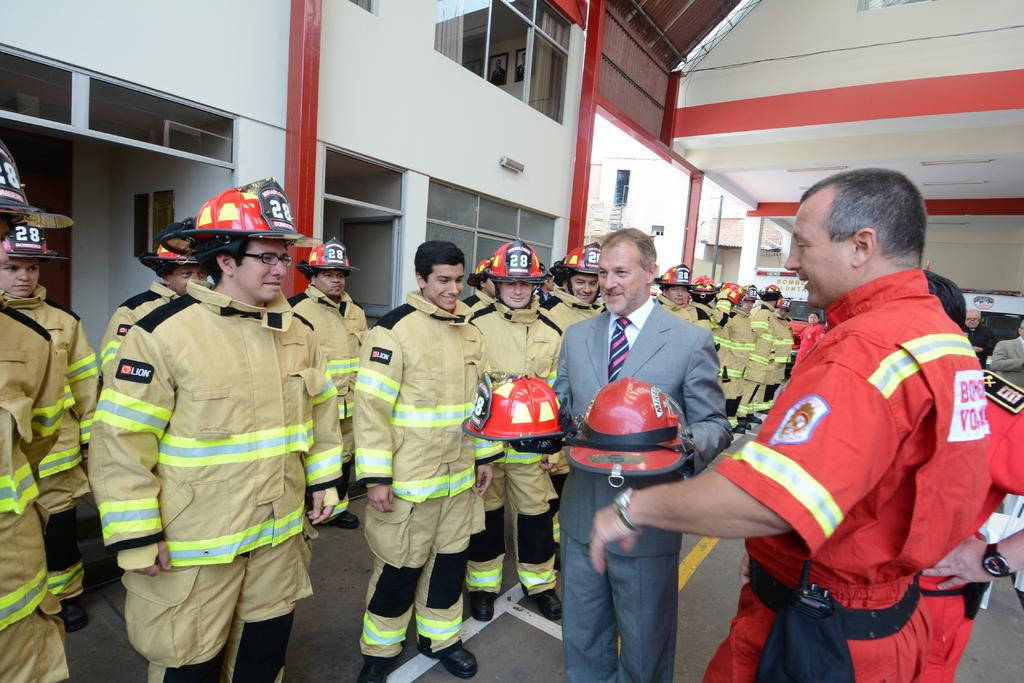What is the main subject of the image? The main subject of the image is a crowd of people. Where are the people standing in the image? The people are standing on the floor. What can be seen in the background of the image? There are buildings, air conditioners, and windows visible in the background of the image. How many pins are being used by the people in the image? There is no mention of pins in the image, so it is not possible to determine how many are being used. 